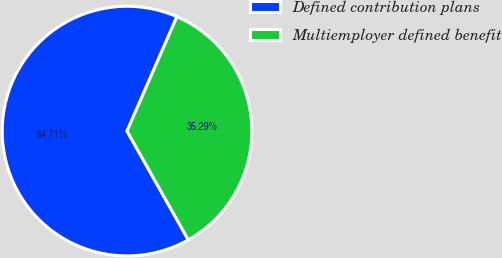Convert chart. <chart><loc_0><loc_0><loc_500><loc_500><pie_chart><fcel>Defined contribution plans<fcel>Multiemployer defined benefit<nl><fcel>64.71%<fcel>35.29%<nl></chart> 